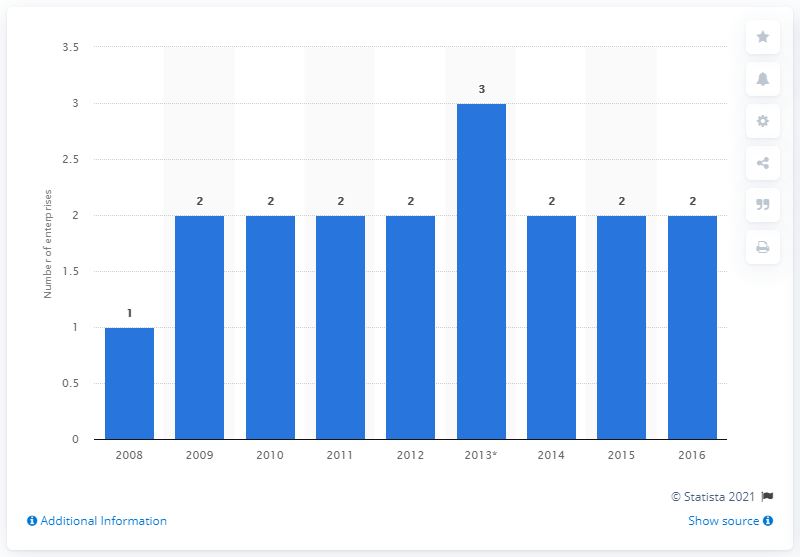Outline some significant characteristics in this image. In 2014, there were two enterprises manufacturing cement in Finland. 